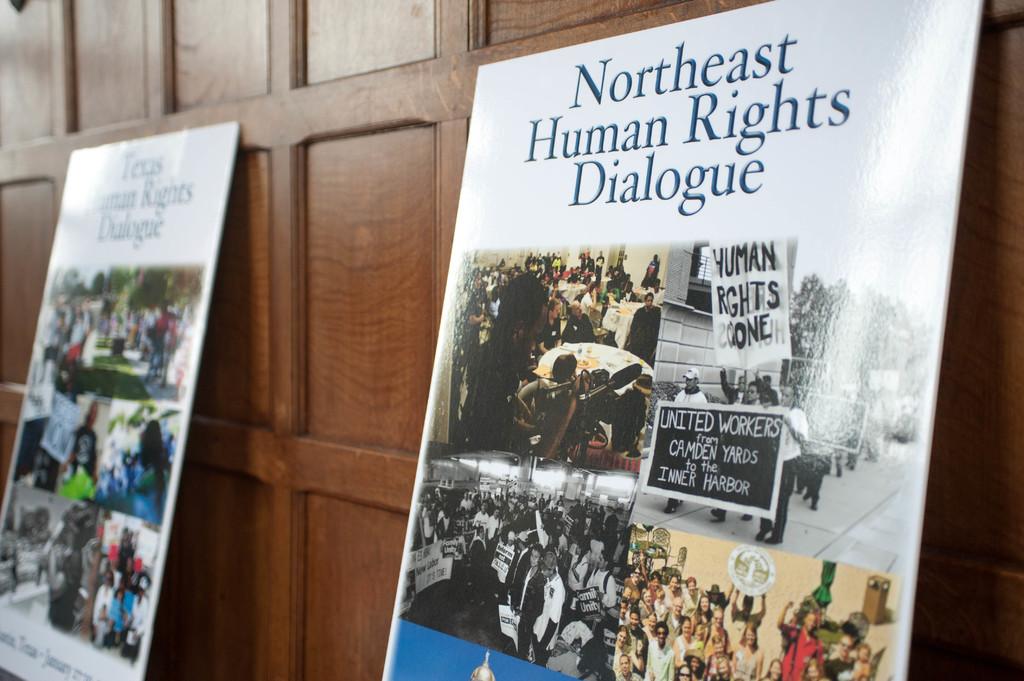What do the signs say this is for?
Keep it short and to the point. Northeast human rights dialogue. Where are the united workers from?
Give a very brief answer. Camden yards. 